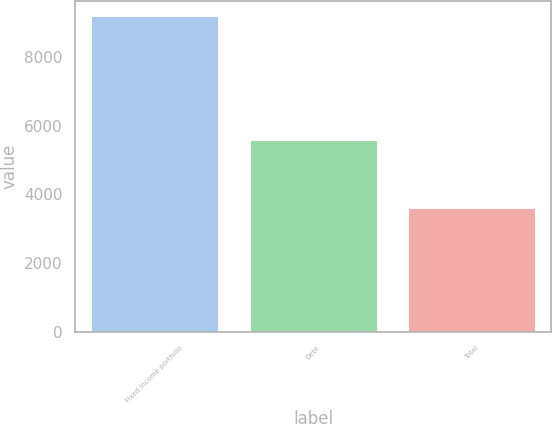<chart> <loc_0><loc_0><loc_500><loc_500><bar_chart><fcel>Fixed income portfolio<fcel>Debt<fcel>Total<nl><fcel>9169<fcel>5567<fcel>3602<nl></chart> 